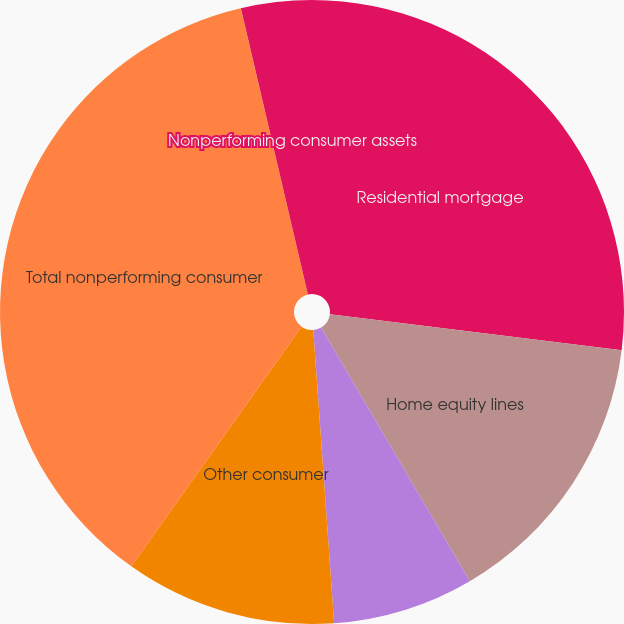Convert chart. <chart><loc_0><loc_0><loc_500><loc_500><pie_chart><fcel>Residential mortgage<fcel>Home equity lines<fcel>Direct/Indirect consumer<fcel>Other consumer<fcel>Total nonperforming consumer<fcel>Nonperforming consumer loans<fcel>Nonperforming consumer assets<nl><fcel>26.95%<fcel>14.61%<fcel>7.31%<fcel>10.96%<fcel>36.5%<fcel>0.01%<fcel>3.66%<nl></chart> 